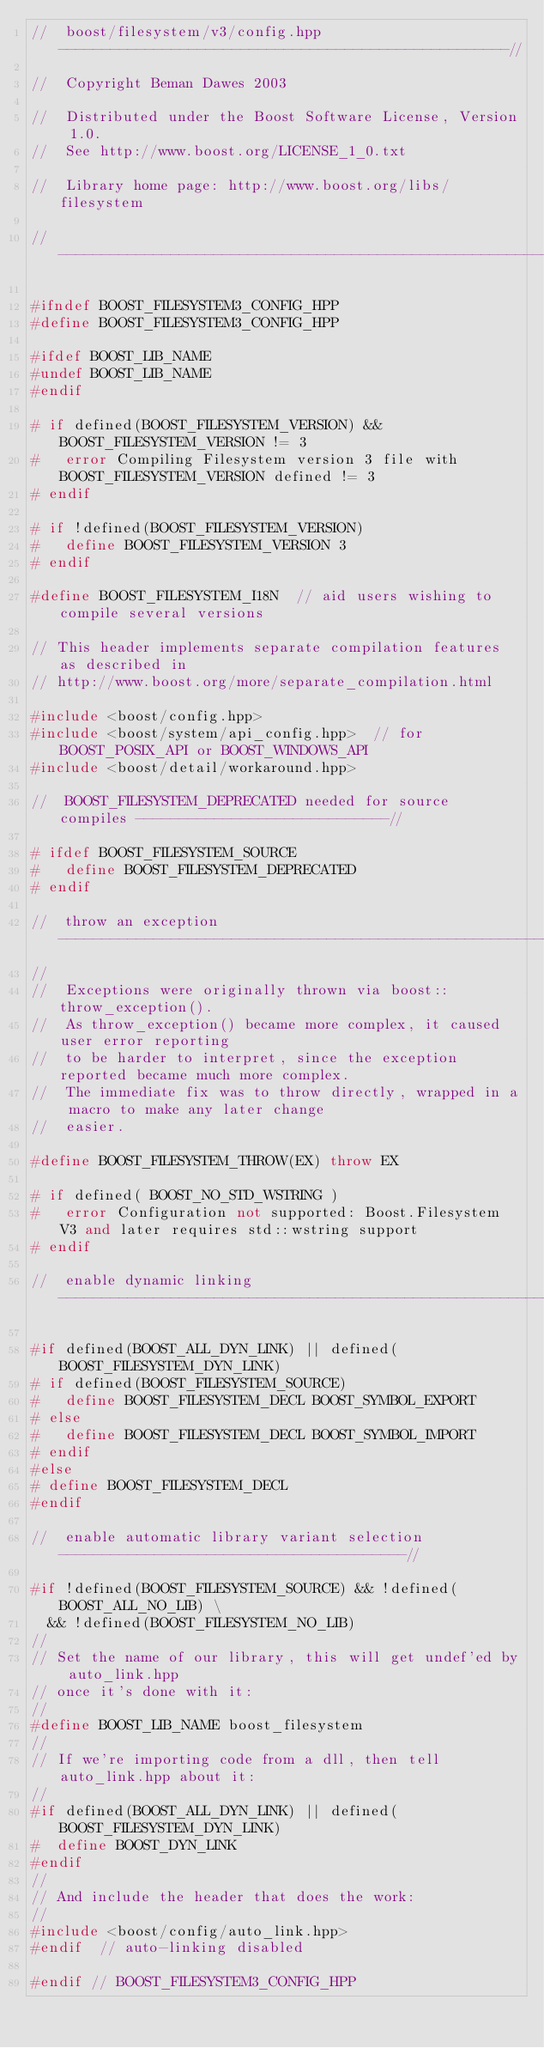<code> <loc_0><loc_0><loc_500><loc_500><_C++_>//  boost/filesystem/v3/config.hpp  ----------------------------------------------------//

//  Copyright Beman Dawes 2003

//  Distributed under the Boost Software License, Version 1.0.
//  See http://www.boost.org/LICENSE_1_0.txt

//  Library home page: http://www.boost.org/libs/filesystem

//--------------------------------------------------------------------------------------// 

#ifndef BOOST_FILESYSTEM3_CONFIG_HPP
#define BOOST_FILESYSTEM3_CONFIG_HPP

#ifdef BOOST_LIB_NAME
#undef BOOST_LIB_NAME
#endif

# if defined(BOOST_FILESYSTEM_VERSION) && BOOST_FILESYSTEM_VERSION != 3
#   error Compiling Filesystem version 3 file with BOOST_FILESYSTEM_VERSION defined != 3
# endif

# if !defined(BOOST_FILESYSTEM_VERSION)
#   define BOOST_FILESYSTEM_VERSION 3
# endif

#define BOOST_FILESYSTEM_I18N  // aid users wishing to compile several versions

// This header implements separate compilation features as described in
// http://www.boost.org/more/separate_compilation.html

#include <boost/config.hpp>
#include <boost/system/api_config.hpp>  // for BOOST_POSIX_API or BOOST_WINDOWS_API
#include <boost/detail/workaround.hpp> 

//  BOOST_FILESYSTEM_DEPRECATED needed for source compiles -----------------------------//

# ifdef BOOST_FILESYSTEM_SOURCE
#   define BOOST_FILESYSTEM_DEPRECATED
# endif

//  throw an exception  ----------------------------------------------------------------//
//
//  Exceptions were originally thrown via boost::throw_exception().
//  As throw_exception() became more complex, it caused user error reporting
//  to be harder to interpret, since the exception reported became much more complex.
//  The immediate fix was to throw directly, wrapped in a macro to make any later change
//  easier.

#define BOOST_FILESYSTEM_THROW(EX) throw EX

# if defined( BOOST_NO_STD_WSTRING )
#   error Configuration not supported: Boost.Filesystem V3 and later requires std::wstring support
# endif

//  enable dynamic linking -------------------------------------------------------------//

#if defined(BOOST_ALL_DYN_LINK) || defined(BOOST_FILESYSTEM_DYN_LINK)
# if defined(BOOST_FILESYSTEM_SOURCE)
#   define BOOST_FILESYSTEM_DECL BOOST_SYMBOL_EXPORT
# else 
#   define BOOST_FILESYSTEM_DECL BOOST_SYMBOL_IMPORT
# endif
#else
# define BOOST_FILESYSTEM_DECL
#endif

//  enable automatic library variant selection  ----------------------------------------// 

#if !defined(BOOST_FILESYSTEM_SOURCE) && !defined(BOOST_ALL_NO_LIB) \
  && !defined(BOOST_FILESYSTEM_NO_LIB)
//
// Set the name of our library, this will get undef'ed by auto_link.hpp
// once it's done with it:
//
#define BOOST_LIB_NAME boost_filesystem
//
// If we're importing code from a dll, then tell auto_link.hpp about it:
//
#if defined(BOOST_ALL_DYN_LINK) || defined(BOOST_FILESYSTEM_DYN_LINK)
#  define BOOST_DYN_LINK
#endif
//
// And include the header that does the work:
//
#include <boost/config/auto_link.hpp>
#endif  // auto-linking disabled

#endif // BOOST_FILESYSTEM3_CONFIG_HPP
</code> 